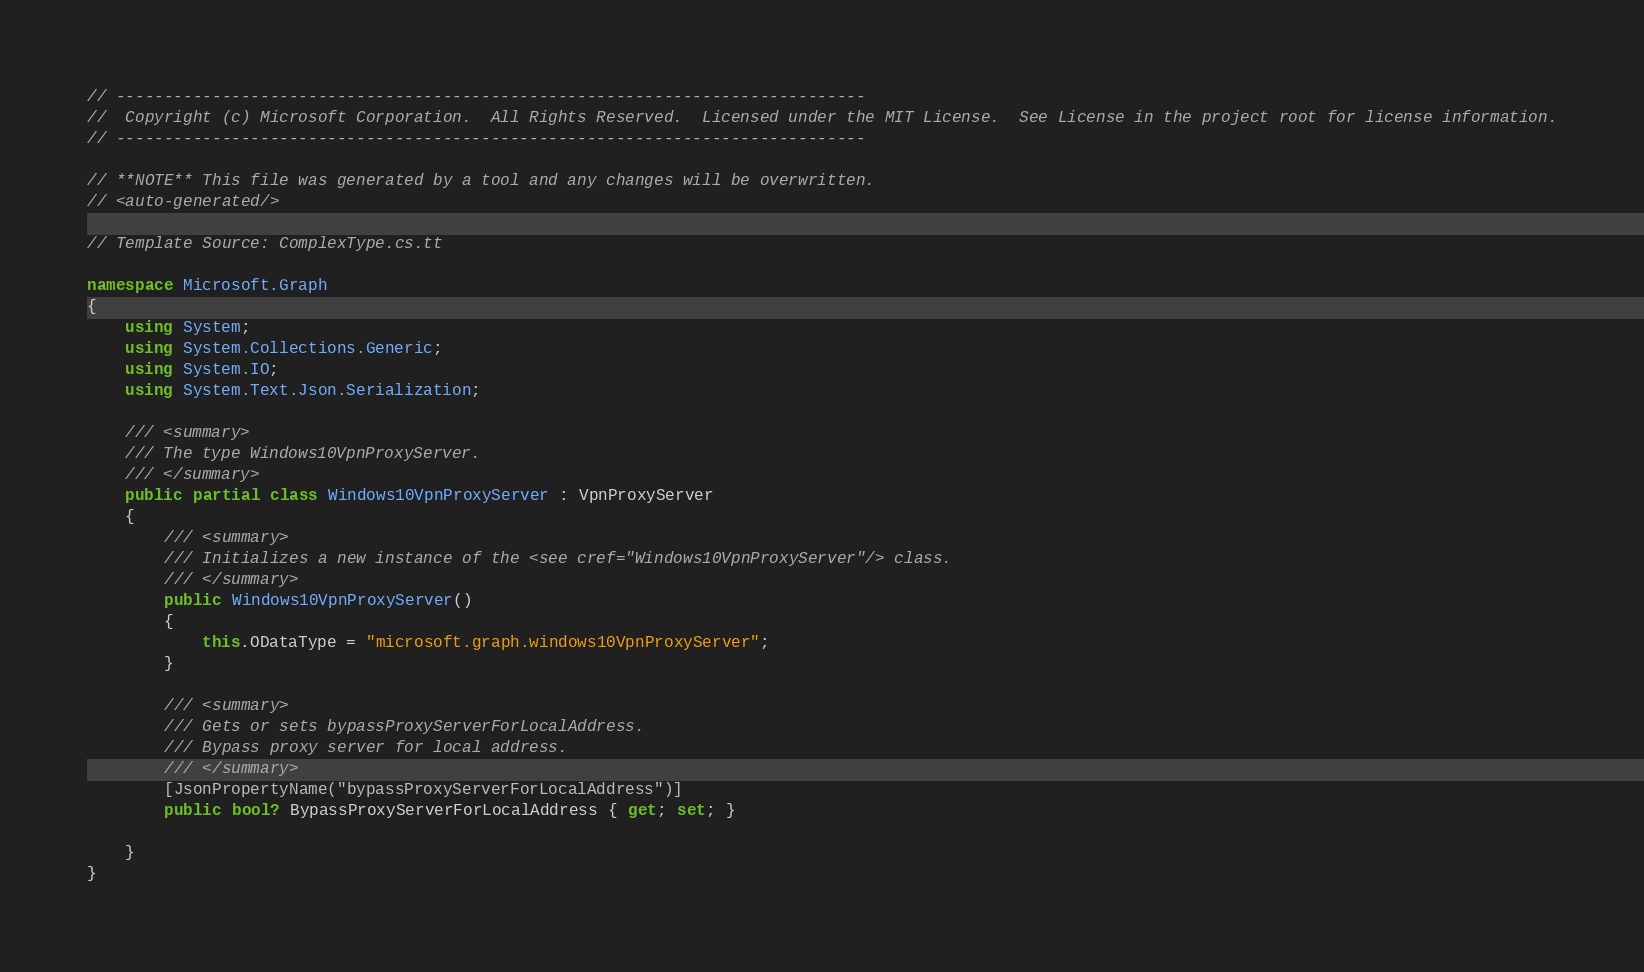Convert code to text. <code><loc_0><loc_0><loc_500><loc_500><_C#_>// ------------------------------------------------------------------------------
//  Copyright (c) Microsoft Corporation.  All Rights Reserved.  Licensed under the MIT License.  See License in the project root for license information.
// ------------------------------------------------------------------------------

// **NOTE** This file was generated by a tool and any changes will be overwritten.
// <auto-generated/>

// Template Source: ComplexType.cs.tt

namespace Microsoft.Graph
{
    using System;
    using System.Collections.Generic;
    using System.IO;
    using System.Text.Json.Serialization;

    /// <summary>
    /// The type Windows10VpnProxyServer.
    /// </summary>
    public partial class Windows10VpnProxyServer : VpnProxyServer
    {
        /// <summary>
        /// Initializes a new instance of the <see cref="Windows10VpnProxyServer"/> class.
        /// </summary>
        public Windows10VpnProxyServer()
        {
            this.ODataType = "microsoft.graph.windows10VpnProxyServer";
        }

        /// <summary>
        /// Gets or sets bypassProxyServerForLocalAddress.
        /// Bypass proxy server for local address.
        /// </summary>
        [JsonPropertyName("bypassProxyServerForLocalAddress")]
        public bool? BypassProxyServerForLocalAddress { get; set; }
    
    }
}
</code> 